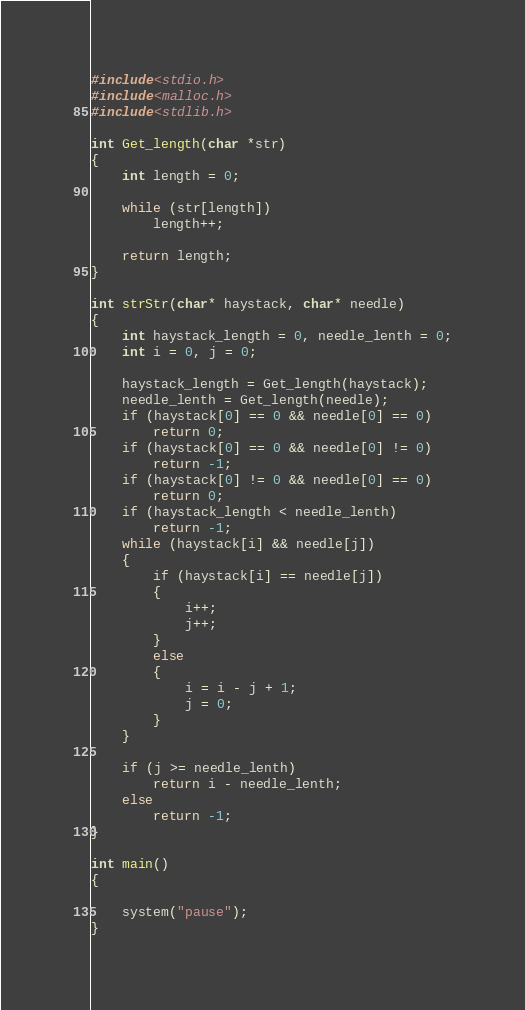Convert code to text. <code><loc_0><loc_0><loc_500><loc_500><_C_>#include<stdio.h>
#include<malloc.h>
#include<stdlib.h>

int Get_length(char *str)
{
	int length = 0;

	while (str[length])
		length++;

	return length;
}

int strStr(char* haystack, char* needle)
{
	int haystack_length = 0, needle_lenth = 0;
	int i = 0, j = 0;

	haystack_length = Get_length(haystack);
	needle_lenth = Get_length(needle);
	if (haystack[0] == 0 && needle[0] == 0)
		return 0;
	if (haystack[0] == 0 && needle[0] != 0)
		return -1;
	if (haystack[0] != 0 && needle[0] == 0)
		return 0;
	if (haystack_length < needle_lenth)
		return -1;
	while (haystack[i] && needle[j])
	{
		if (haystack[i] == needle[j])
		{
			i++;
			j++;
		}
		else
		{
			i = i - j + 1;
			j = 0;
		}
	}

	if (j >= needle_lenth)
		return i - needle_lenth;
	else
		return -1;
}

int main()
{

	system("pause");
}</code> 